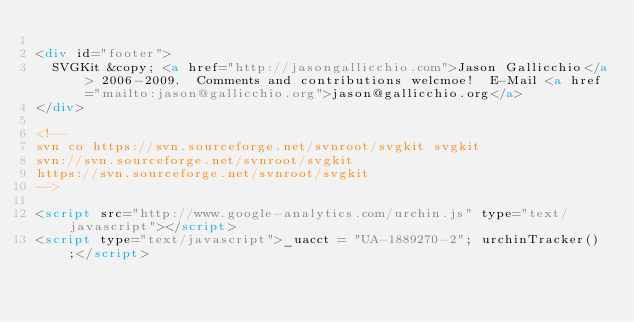<code> <loc_0><loc_0><loc_500><loc_500><_HTML_>
<div id="footer">
  SVGKit &copy; <a href="http://jasongallicchio.com">Jason Gallicchio</a> 2006-2009.  Comments and contributions welcmoe!  E-Mail <a href="mailto:jason@gallicchio.org">jason@gallicchio.org</a>
</div>

<!--
svn co https://svn.sourceforge.net/svnroot/svgkit svgkit
svn://svn.sourceforge.net/svnroot/svgkit
https://svn.sourceforge.net/svnroot/svgkit
-->

<script src="http://www.google-analytics.com/urchin.js" type="text/javascript"></script>
<script type="text/javascript">_uacct = "UA-1889270-2"; urchinTracker();</script>
</code> 